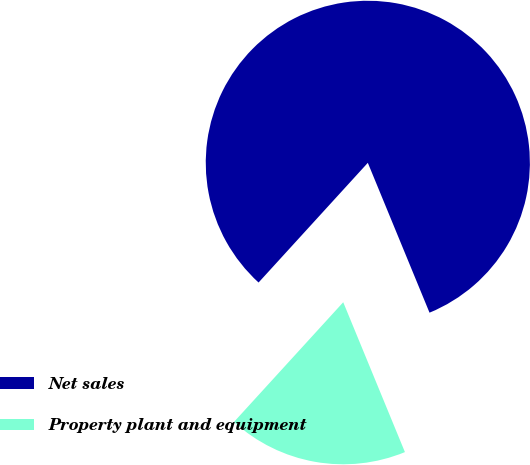Convert chart to OTSL. <chart><loc_0><loc_0><loc_500><loc_500><pie_chart><fcel>Net sales<fcel>Property plant and equipment<nl><fcel>82.01%<fcel>17.99%<nl></chart> 